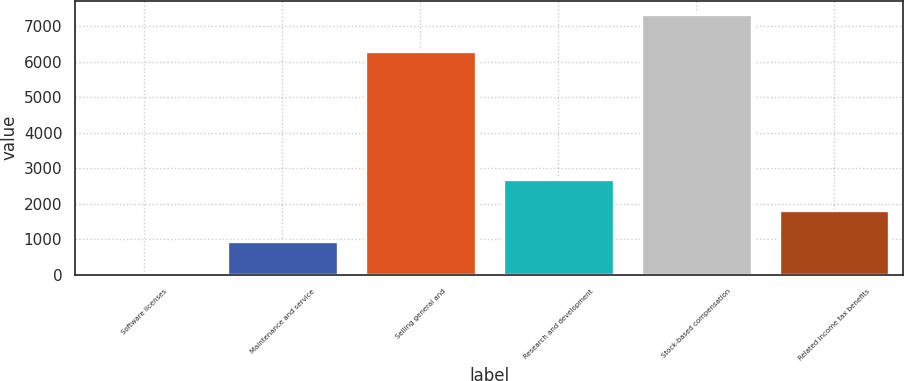Convert chart. <chart><loc_0><loc_0><loc_500><loc_500><bar_chart><fcel>Software licenses<fcel>Maintenance and service<fcel>Selling general and<fcel>Research and development<fcel>Stock-based compensation<fcel>Related income tax benefits<nl><fcel>52<fcel>938.6<fcel>6299<fcel>2711.8<fcel>7352<fcel>1825.2<nl></chart> 